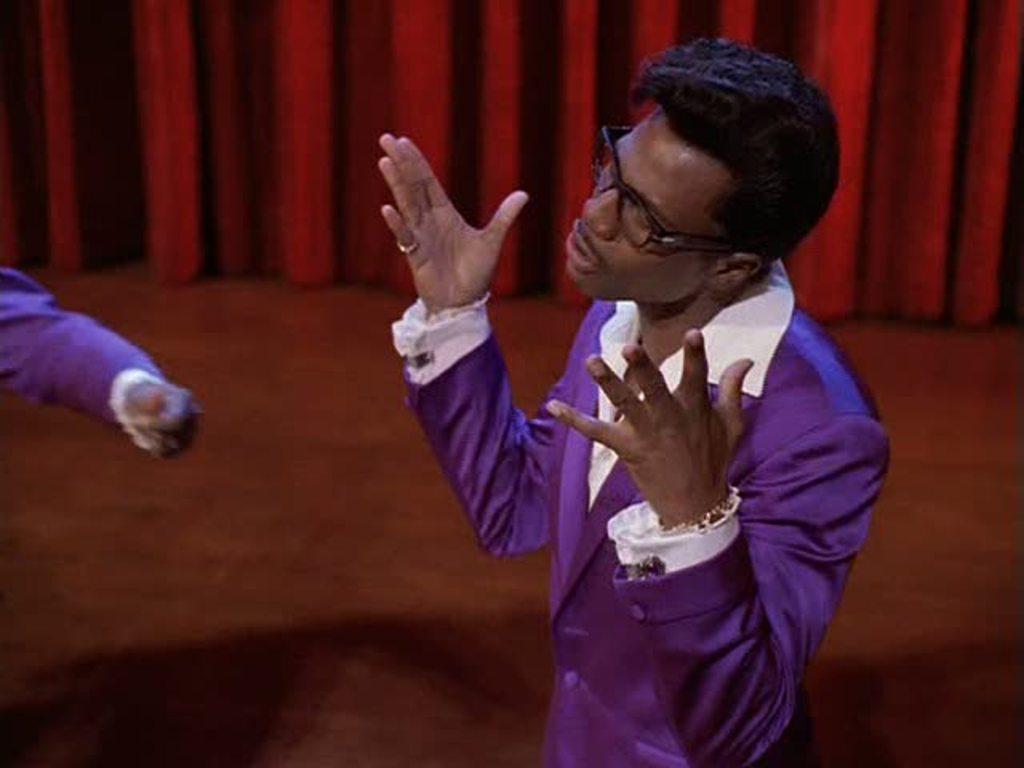Could you give a brief overview of what you see in this image? In this picture I can see a person wearing spectacles and standing, side there is another person hand and behind I can see a red color curtain hanged. 